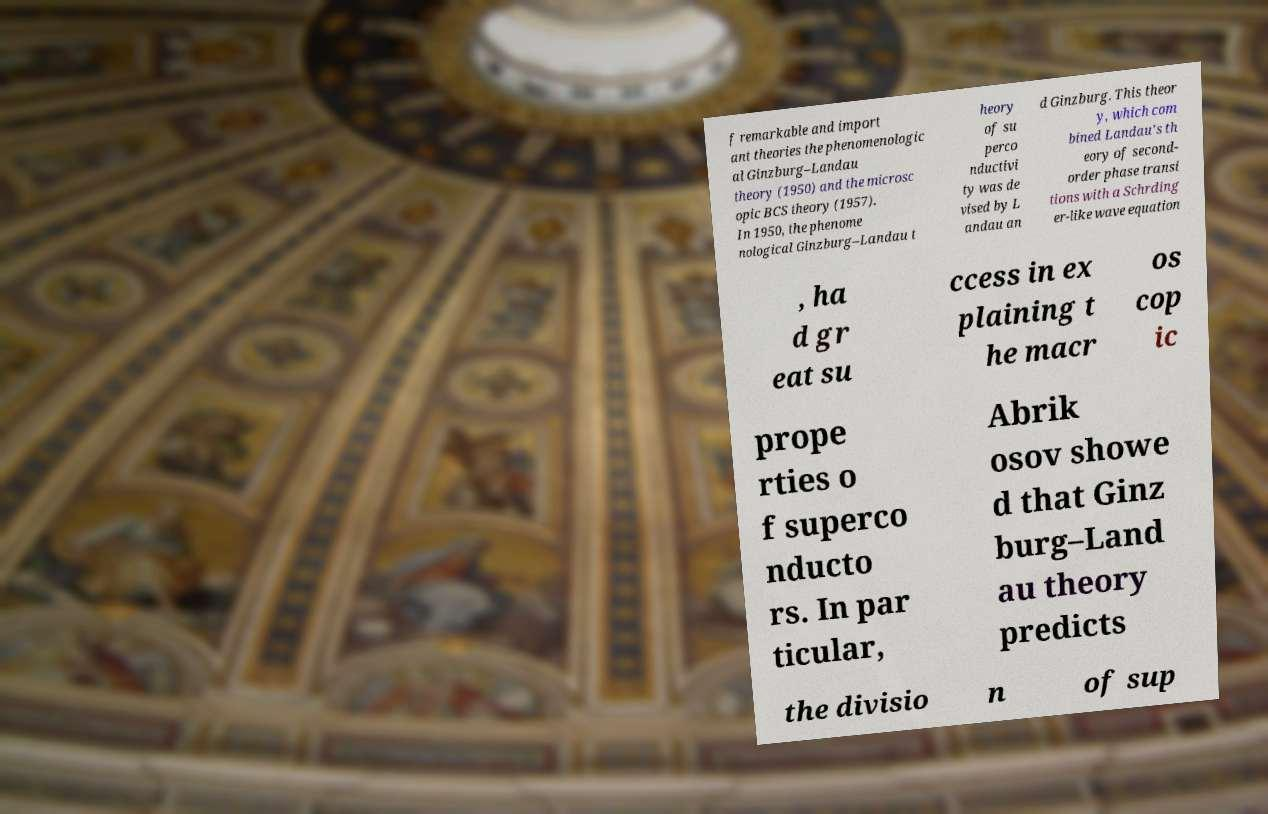Can you read and provide the text displayed in the image?This photo seems to have some interesting text. Can you extract and type it out for me? f remarkable and import ant theories the phenomenologic al Ginzburg–Landau theory (1950) and the microsc opic BCS theory (1957). In 1950, the phenome nological Ginzburg–Landau t heory of su perco nductivi ty was de vised by L andau an d Ginzburg. This theor y, which com bined Landau's th eory of second- order phase transi tions with a Schrding er-like wave equation , ha d gr eat su ccess in ex plaining t he macr os cop ic prope rties o f superco nducto rs. In par ticular, Abrik osov showe d that Ginz burg–Land au theory predicts the divisio n of sup 